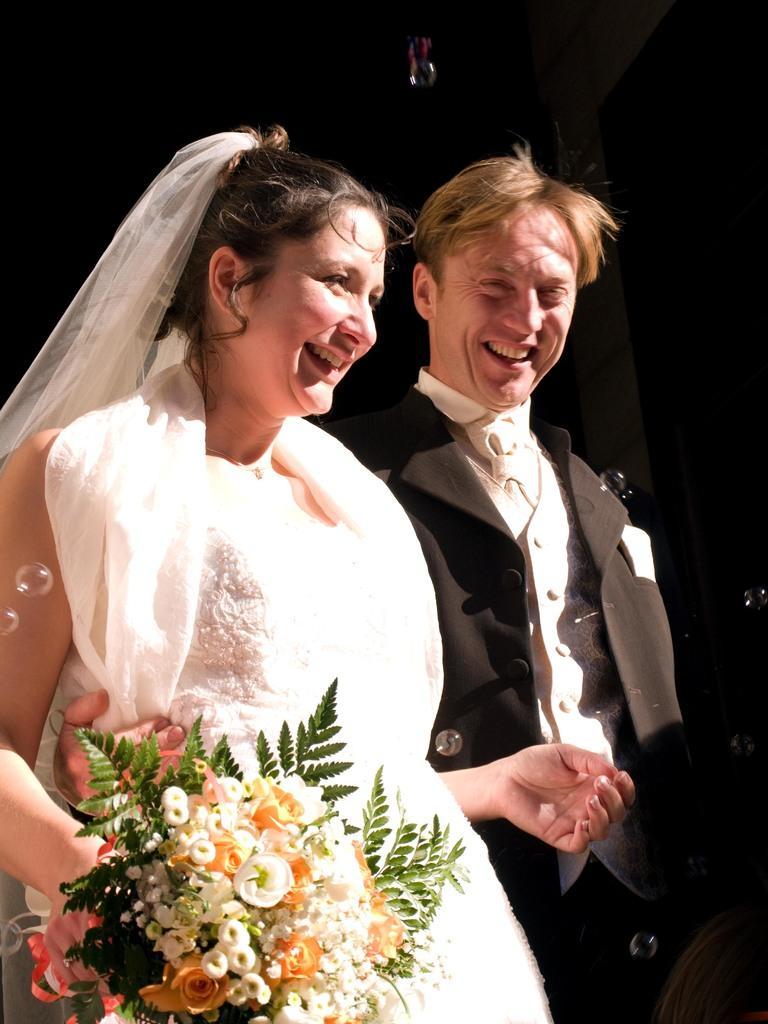Can you describe this image briefly? In this image we can see a man in black suit and a woman in white dress with a bouquet and are standing and smiling. 